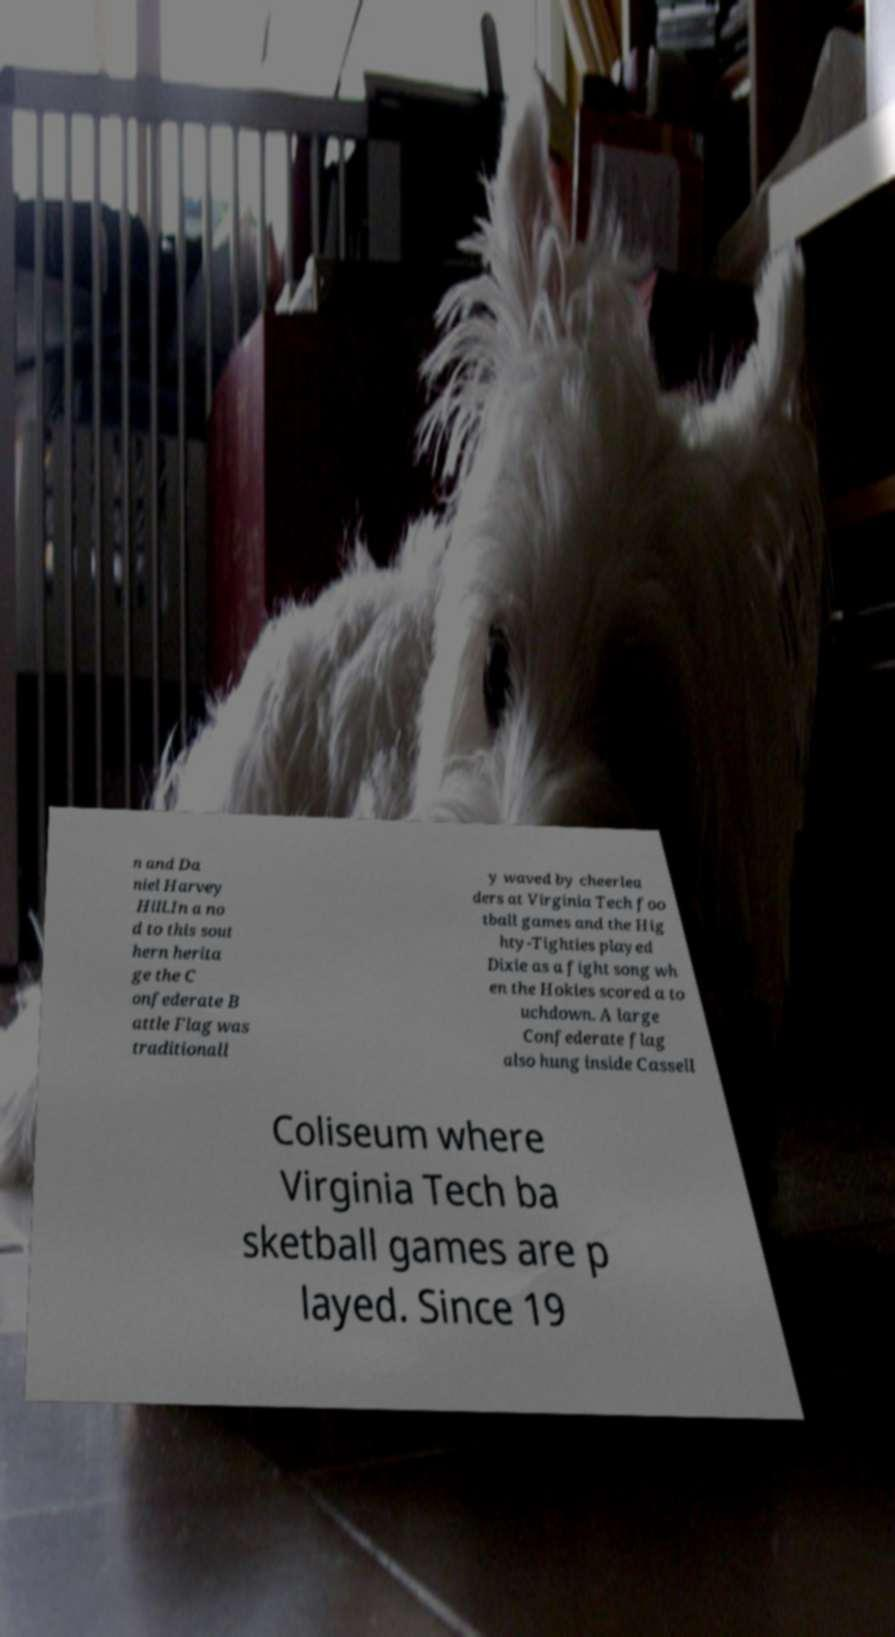There's text embedded in this image that I need extracted. Can you transcribe it verbatim? n and Da niel Harvey Hill.In a no d to this sout hern herita ge the C onfederate B attle Flag was traditionall y waved by cheerlea ders at Virginia Tech foo tball games and the Hig hty-Tighties played Dixie as a fight song wh en the Hokies scored a to uchdown. A large Confederate flag also hung inside Cassell Coliseum where Virginia Tech ba sketball games are p layed. Since 19 